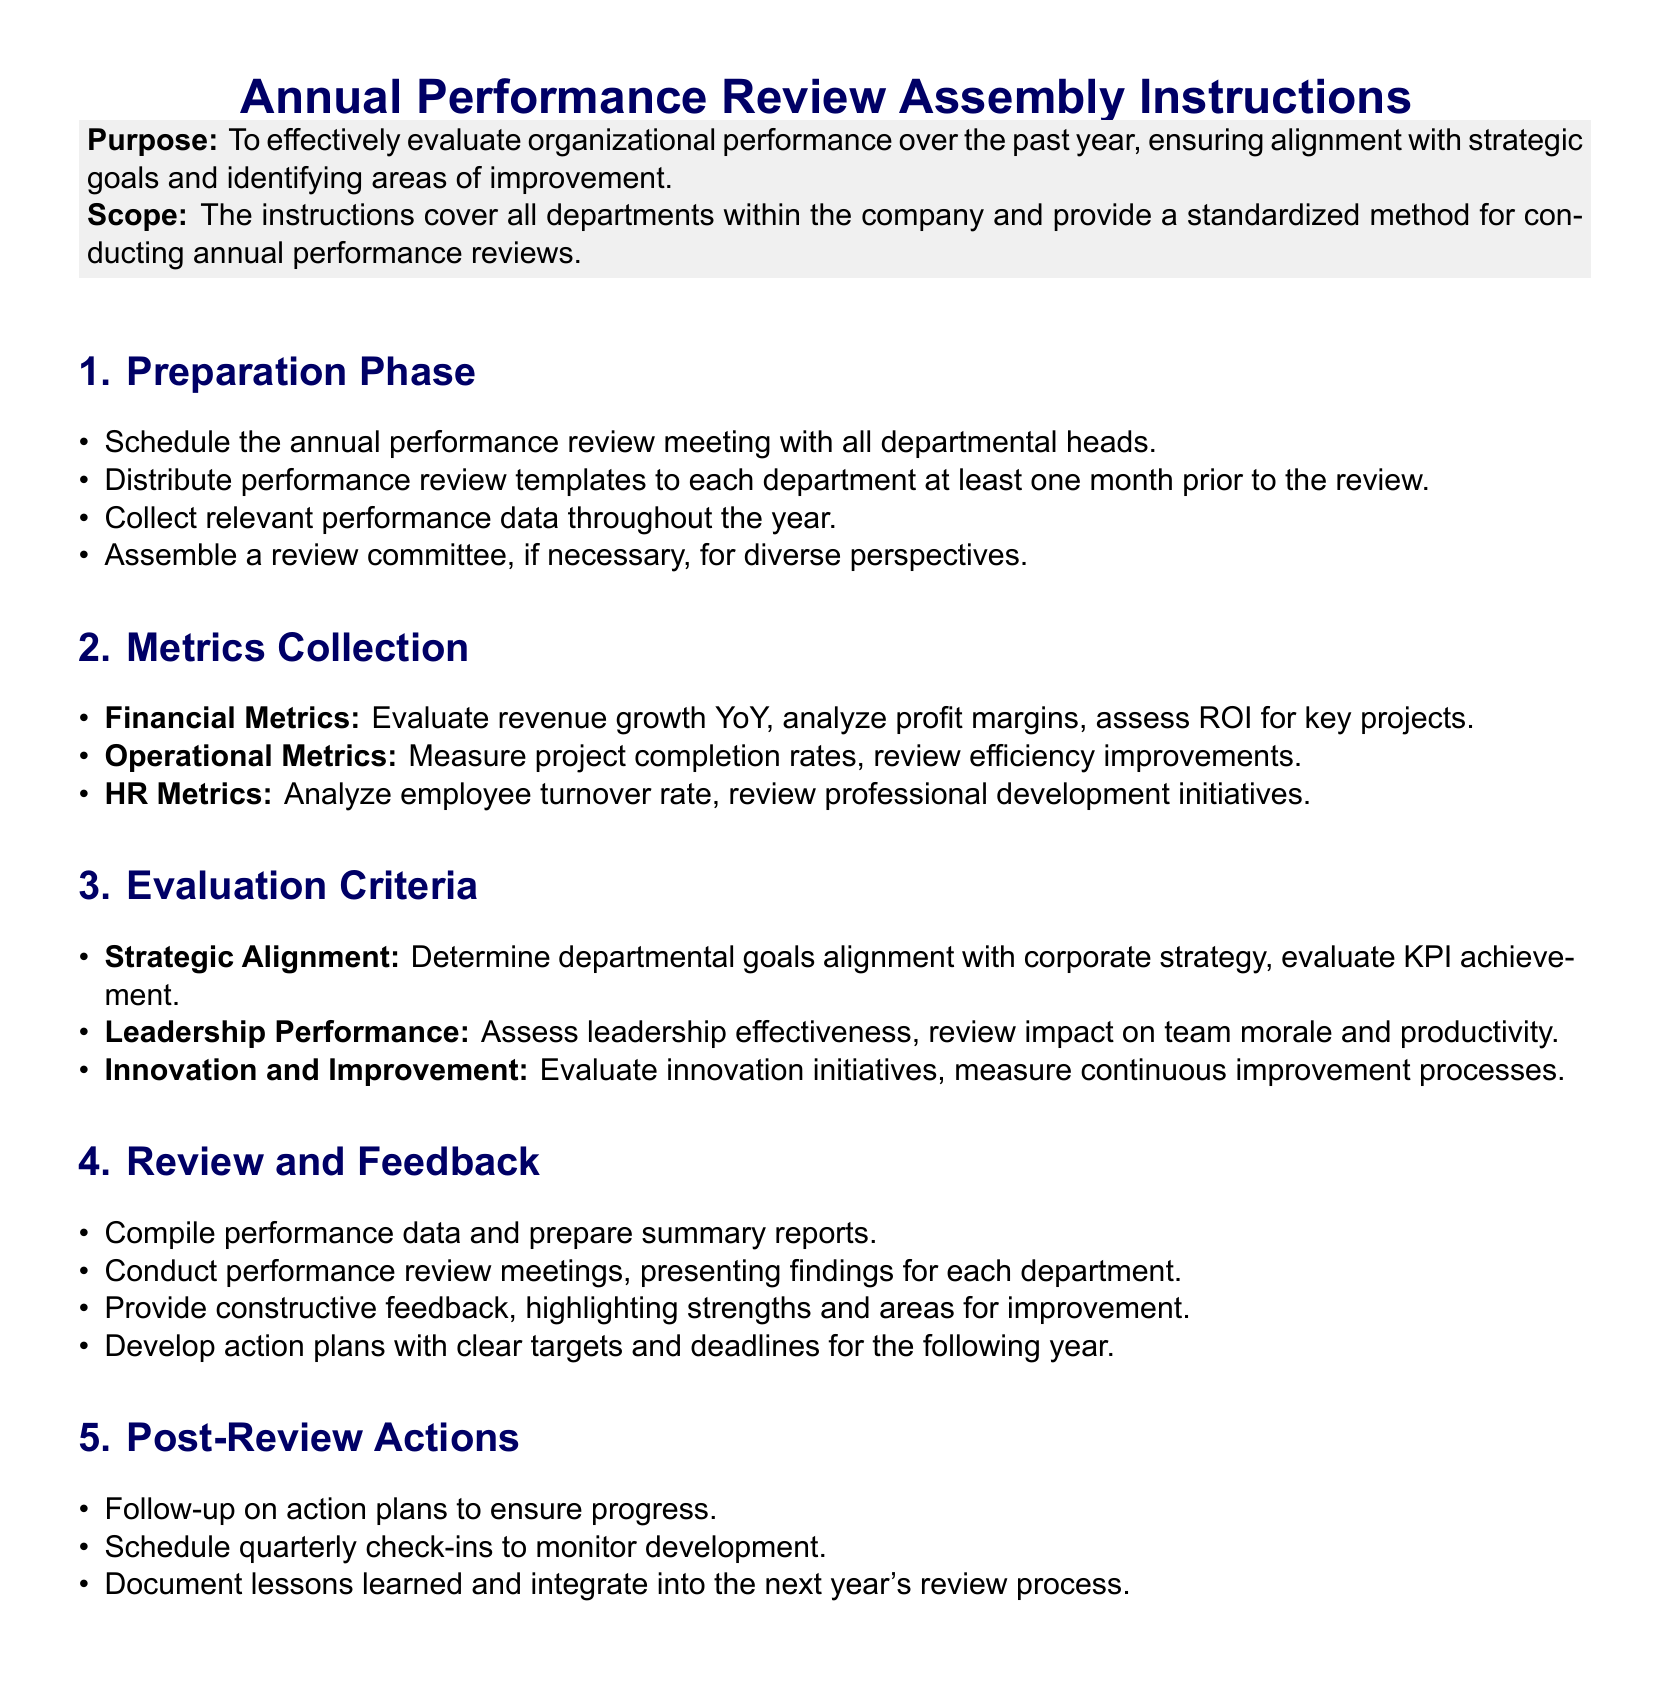What is the purpose of the annual performance review? The purpose is to effectively evaluate organizational performance over the past year, ensuring alignment with strategic goals and identifying areas of improvement.
Answer: To effectively evaluate organizational performance over the past year, ensuring alignment with strategic goals and identifying areas of improvement How many phases are outlined in the assembly instructions? The assembly instructions outline five phases as indicated in the document.
Answer: Five phases What is one of the financial metrics to evaluate? Financial metrics include revenue growth year-over-year, which is one of the specific metrics listed.
Answer: Revenue growth YoY What is the focus of the review and feedback section? The focus is on compiling performance data and preparing summary reports for each department's performance review meetings.
Answer: Compiling performance data and preparing summary reports Which metric assesses leadership effectiveness? Leadership performance assesses leadership effectiveness as stated in the evaluation criteria.
Answer: Leadership performance What type of committees can be assembled for the review process? A review committee can be assembled for diverse perspectives, as mentioned in the preparation phase.
Answer: Review committee What action follows the performance review meetings? Developing action plans with clear targets and deadlines for the following year follows the performance review meetings.
Answer: Develop action plans What is the aim of the post-review actions? The aim is to ensure progress on action plans and schedule quarterly check-ins to monitor development.
Answer: To ensure progress on action plans 